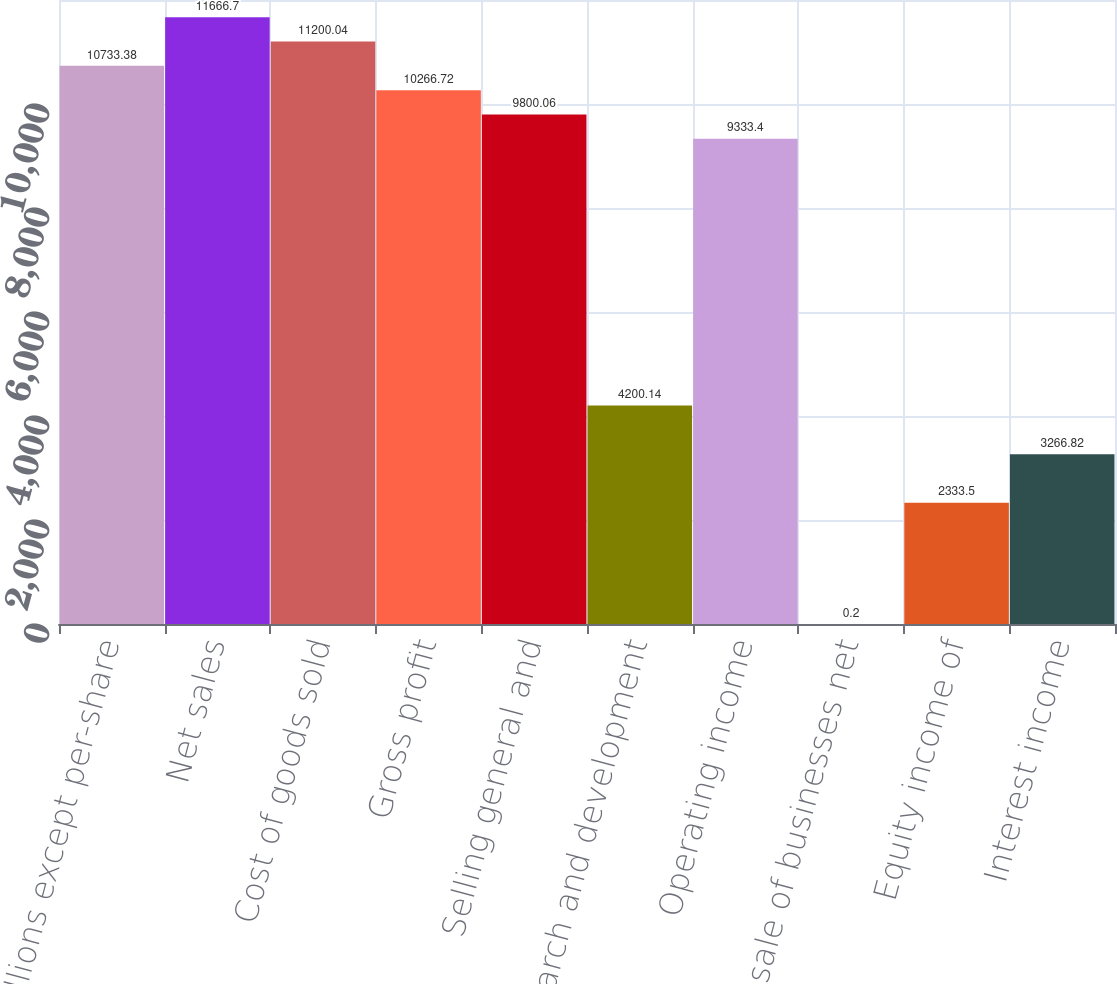Convert chart. <chart><loc_0><loc_0><loc_500><loc_500><bar_chart><fcel>In millions except per-share<fcel>Net sales<fcel>Cost of goods sold<fcel>Gross profit<fcel>Selling general and<fcel>Research and development<fcel>Operating income<fcel>Loss on sale of businesses net<fcel>Equity income of<fcel>Interest income<nl><fcel>10733.4<fcel>11666.7<fcel>11200<fcel>10266.7<fcel>9800.06<fcel>4200.14<fcel>9333.4<fcel>0.2<fcel>2333.5<fcel>3266.82<nl></chart> 